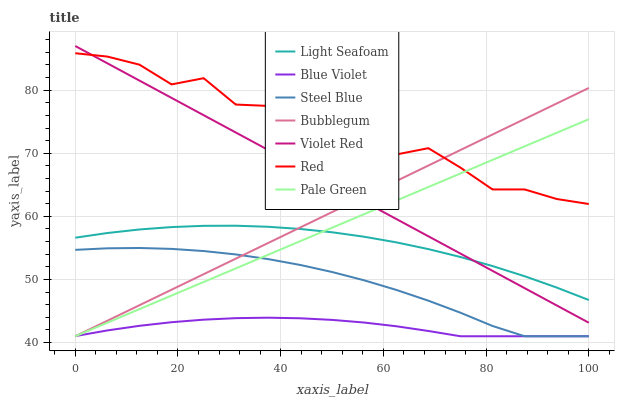Does Blue Violet have the minimum area under the curve?
Answer yes or no. Yes. Does Red have the maximum area under the curve?
Answer yes or no. Yes. Does Steel Blue have the minimum area under the curve?
Answer yes or no. No. Does Steel Blue have the maximum area under the curve?
Answer yes or no. No. Is Bubblegum the smoothest?
Answer yes or no. Yes. Is Red the roughest?
Answer yes or no. Yes. Is Steel Blue the smoothest?
Answer yes or no. No. Is Steel Blue the roughest?
Answer yes or no. No. Does Steel Blue have the lowest value?
Answer yes or no. Yes. Does Red have the lowest value?
Answer yes or no. No. Does Violet Red have the highest value?
Answer yes or no. Yes. Does Steel Blue have the highest value?
Answer yes or no. No. Is Blue Violet less than Red?
Answer yes or no. Yes. Is Light Seafoam greater than Steel Blue?
Answer yes or no. Yes. Does Pale Green intersect Light Seafoam?
Answer yes or no. Yes. Is Pale Green less than Light Seafoam?
Answer yes or no. No. Is Pale Green greater than Light Seafoam?
Answer yes or no. No. Does Blue Violet intersect Red?
Answer yes or no. No. 